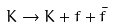<formula> <loc_0><loc_0><loc_500><loc_500>K \rightarrow K + f + \bar { f }</formula> 